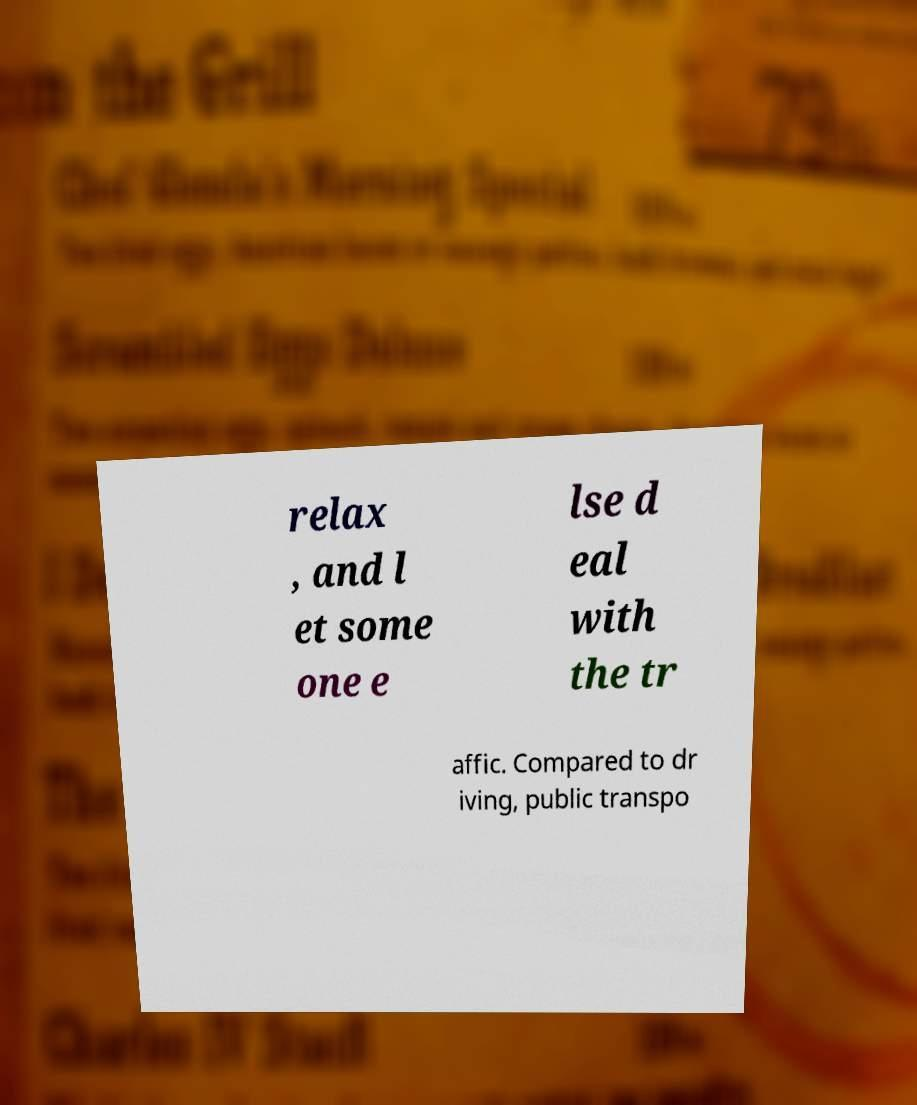Can you accurately transcribe the text from the provided image for me? relax , and l et some one e lse d eal with the tr affic. Compared to dr iving, public transpo 